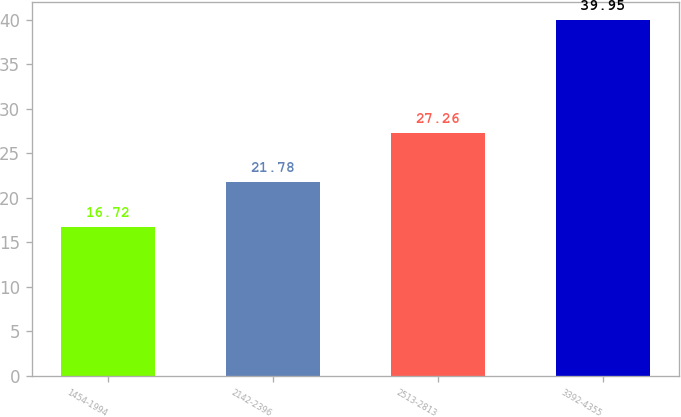<chart> <loc_0><loc_0><loc_500><loc_500><bar_chart><fcel>1454-1994<fcel>2142-2396<fcel>2513-2813<fcel>3392-4355<nl><fcel>16.72<fcel>21.78<fcel>27.26<fcel>39.95<nl></chart> 